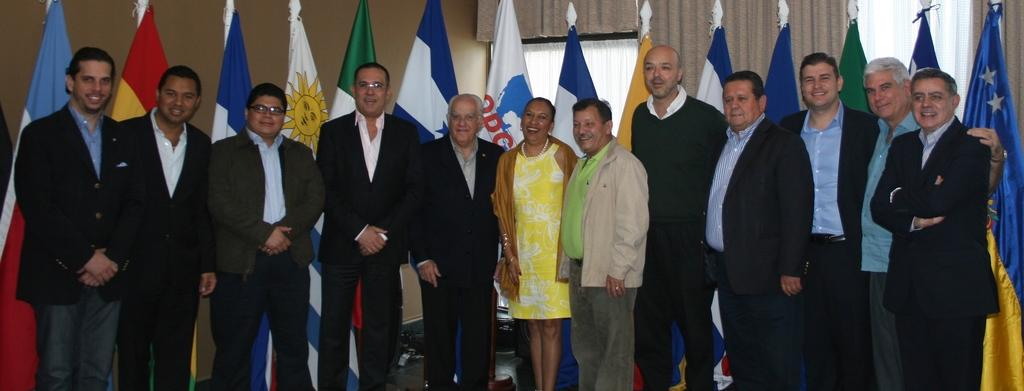How many people are in the image? There is a group of people in the image. Where are the people in the image located? The group of people is standing behind other people. What can be seen in the image besides the people? There are multiple flags and curtains in the image. What type of books are the crows reading in the image? There are no crows or books present in the image. 